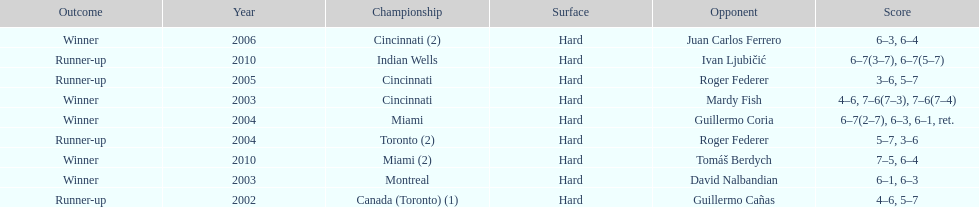What is his highest number of consecutive wins? 3. 